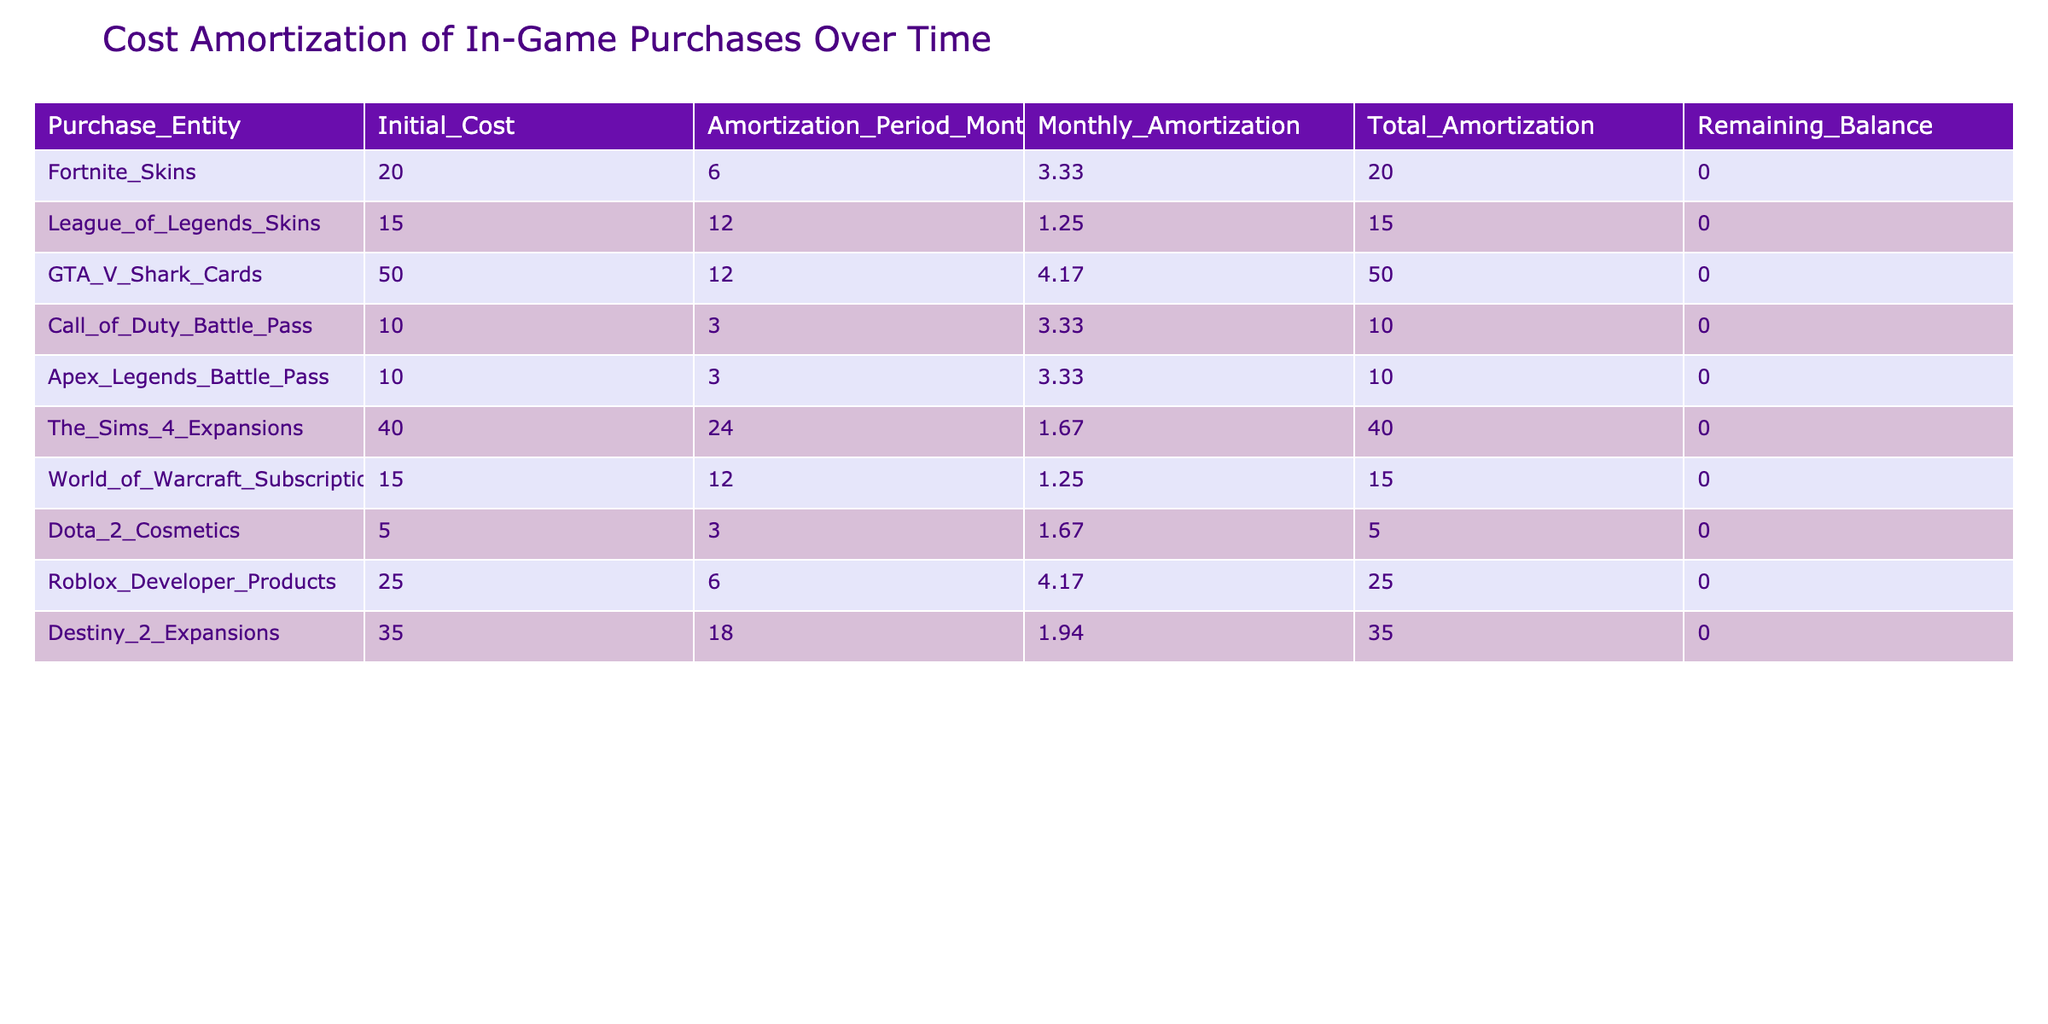What is the initial cost of Fortnite Skins? The table lists the initial cost for each purchase entity. For Fortnite Skins, the initial cost is explicitly stated as $20.00.
Answer: 20.00 How many months is the amortization period for League of Legends Skins? The amortization period is a column in the table. For League of Legends Skins, the period specified is 12 months.
Answer: 12 What is the total amortization for GTA V Shark Cards? The total amortization is shown in the table. For GTA V Shark Cards, the total amortization is noted as $50.00.
Answer: 50.00 Are there any in-game purchases with an initial cost less than $10.00? By reviewing the initial costs in the table, all listed in-game purchases have initial costs equal to or greater than $5.00. Therefore, there are no purchases below $10.00.
Answer: No Which purchase entity has the highest monthly amortization? The monthly amortization values must be compared. Identifying the maximum value in the table shows that Fortnite Skins and Roblox Developer Products both have the highest monthly amortization at $4.17. Though it's a tie, there are two that share the highest value.
Answer: Fortnite Skins and Roblox Developer Products What is the total number of months for all purchases in the table? The total months need to be calculated by summing the amortization periods: 6 + 12 + 12 + 3 + 3 + 24 + 12 + 3 + 6 + 18 = 99 months. Therefore, the total amortization period for all purchases in this table is 99.
Answer: 99 How much is the remaining balance for Call of Duty Battle Pass after the amortization period? According to the table, the remaining balance column for Call of Duty Battle Pass shows $0.00, indicating that the full cost has been amortized.
Answer: 0.00 What is the average monthly amortization for all purchase entities? To find the average monthly amortization, sum all the monthly amortization values and divide by the number of entries: (3.33 + 1.25 + 4.17 + 3.33 + 3.33 + 1.67 + 1.25 + 1.67 + 4.17 + 1.94) = 22.67, divided by 10 gives an average of approximately 2.27.
Answer: 2.27 Is there any purchase that has an amortization period longer than 24 months? The table shows the amortization periods for each purchase, and the longest listed is 24 months for The Sims 4 Expansions. No purchase entity exceeds this period.
Answer: No 